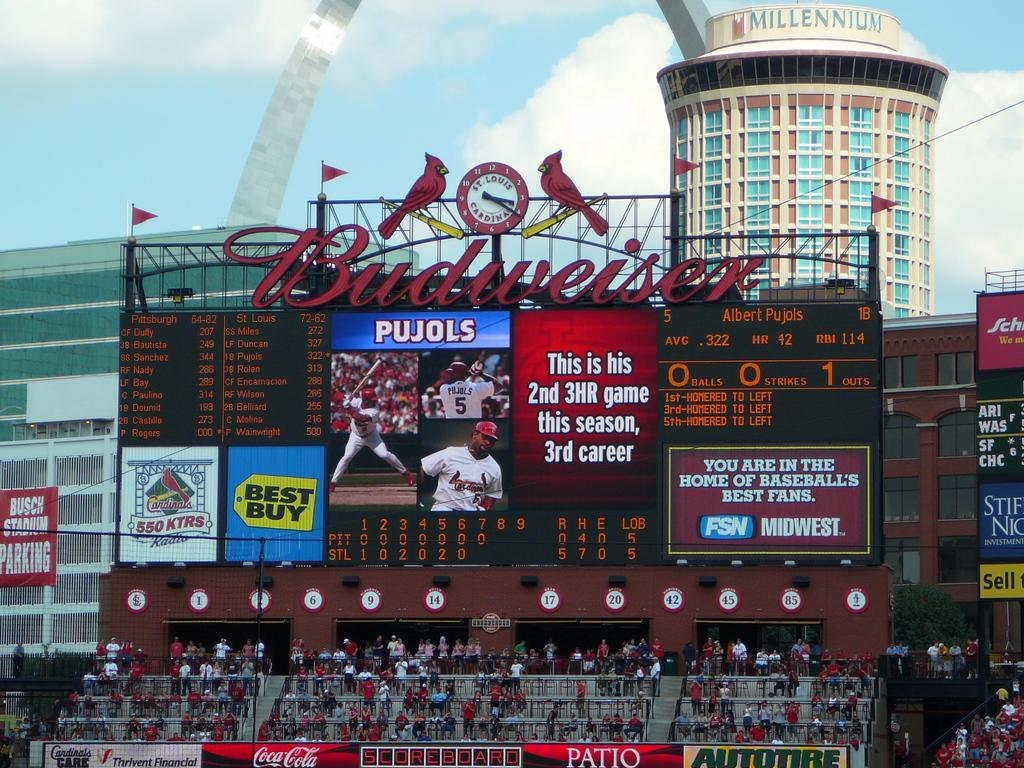<image>
Offer a succinct explanation of the picture presented. a budweiser stadium billboard with several advertisements for best buy and others. 